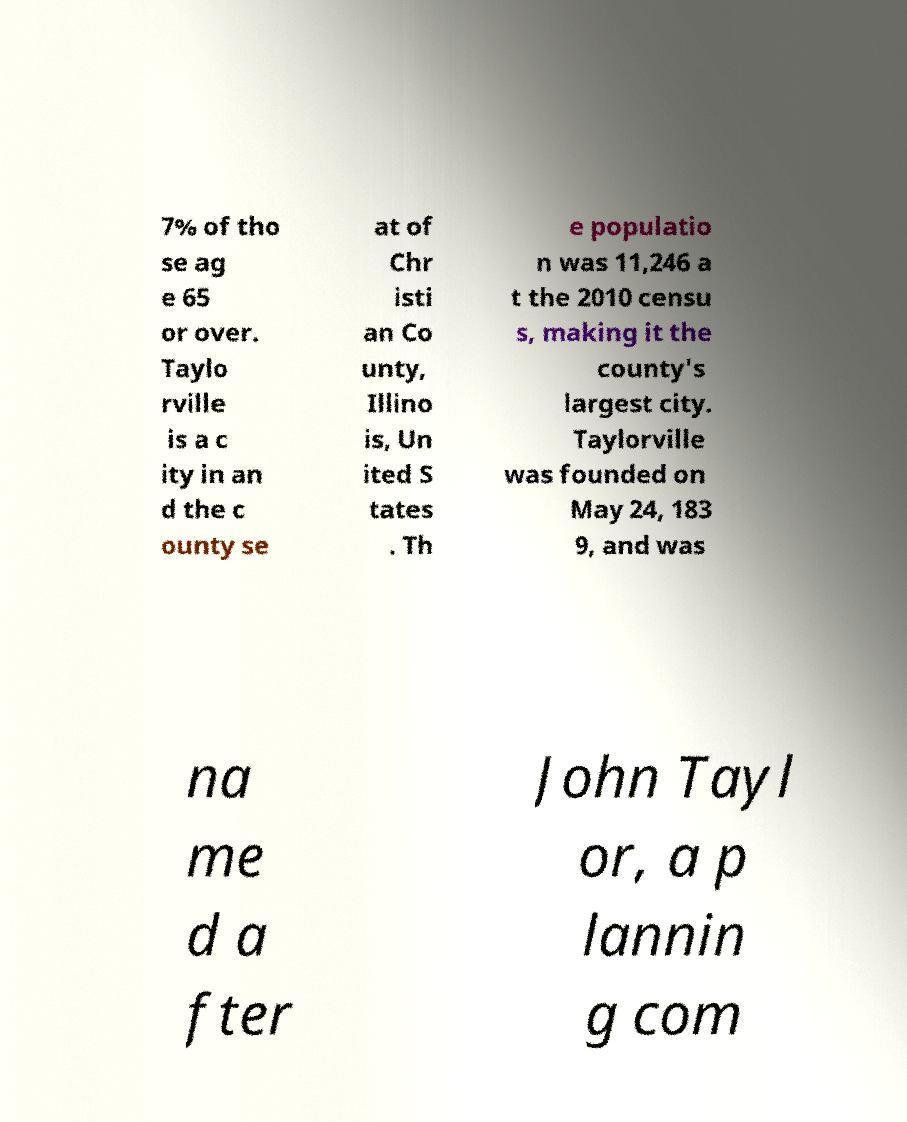Can you read and provide the text displayed in the image?This photo seems to have some interesting text. Can you extract and type it out for me? 7% of tho se ag e 65 or over. Taylo rville is a c ity in an d the c ounty se at of Chr isti an Co unty, Illino is, Un ited S tates . Th e populatio n was 11,246 a t the 2010 censu s, making it the county's largest city. Taylorville was founded on May 24, 183 9, and was na me d a fter John Tayl or, a p lannin g com 